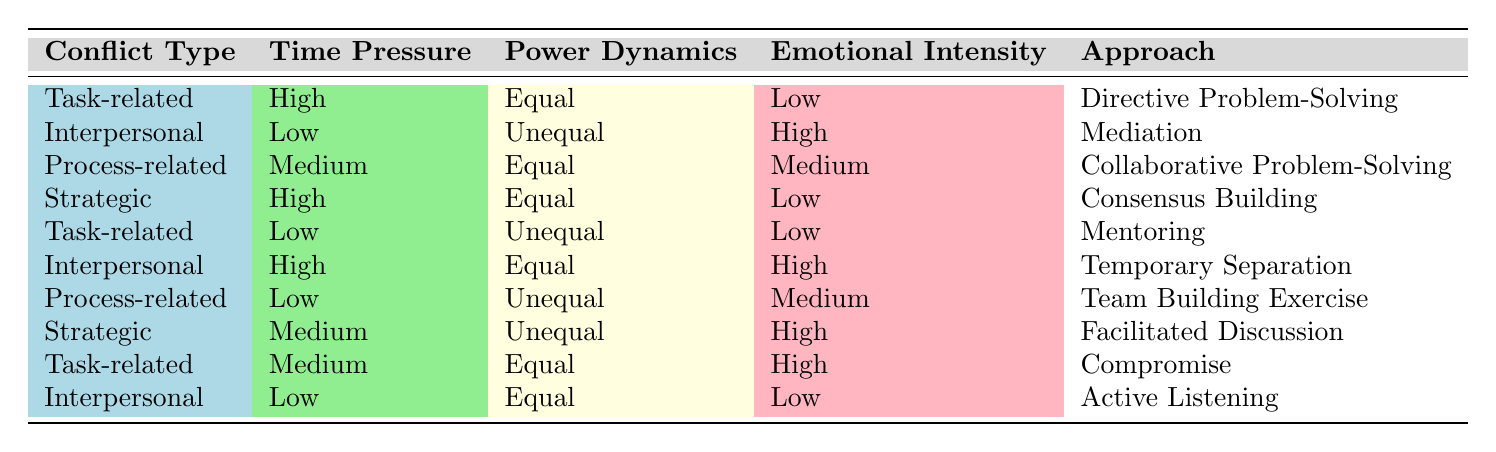What conflict resolution approach is recommended when the conflict type is strategic, time pressure is high, power dynamics are equal, and emotional intensity is low? In the table, for the row that matches the conditions "Strategic" for Conflict Type, "High" for Time Pressure, "Equal" for Power Dynamics, and "Low" for Emotional Intensity, the corresponding approach listed is "Consensus Building".
Answer: Consensus Building What approach is suggested if there is low emotional intensity and an unequal power dynamic in an interpersonal conflict? Looking at the table, we find the row with "Interpersonal" under Conflict Type, "Low" under Emotional Intensity, and "Unequal" under Power Dynamics, which shows the approach to be "Active Listening".
Answer: Active Listening Is mediation an appropriate approach for conflicts that are task-related and have high emotional intensity? The table shows that mediation is associated with "Interpersonal" conflicts, not "Task-related" conflicts, hence mediation is not applicable here.
Answer: No How many approaches are recommended for conflicts that are process-related with low emotional intensity? In the table, there are two rows matching "Process-related" for Conflict Type and "Low" for Emotional Intensity. The approaches for these rows are "Team Building Exercise" and "Collaborative Problem-Solving". Therefore, the total is 2.
Answer: 2 What is the approach for a task-related conflict when the time pressure is medium and emotional intensity is high? The table shows one matching row with "Task-related" under Conflict Type, "Medium" under Time Pressure, and "High" under Emotional Intensity, which indicates the approach to be "Compromise".
Answer: Compromise If the emotional intensity is low and power dynamics are equal in an interpersonal conflict, what resolution approach would be taken? Referring to the table, the row with "Interpersonal" under Conflict Type, "Low" for Emotional Intensity, and "Equal" for Power Dynamics indicates the recommended approach is "Active Listening".
Answer: Active Listening Which approach should be taken for strategic conflicts when power dynamics are unequal and emotional intensity is high? The relevant entry in the table shows that for a "Strategic" conflict, "Unequal" power dynamics, and "High" emotional intensity, the suggested approach is "Facilitated Discussion".
Answer: Facilitated Discussion How many conflict types listed involve a high level of emotional intensity? By examining the table, we see that there are three conflict types labeled "High" for Emotional Intensity: "Interpersonal", "Strategic", and "Task-related". Therefore, the total conflict types with high emotional intensity is 3.
Answer: 3 